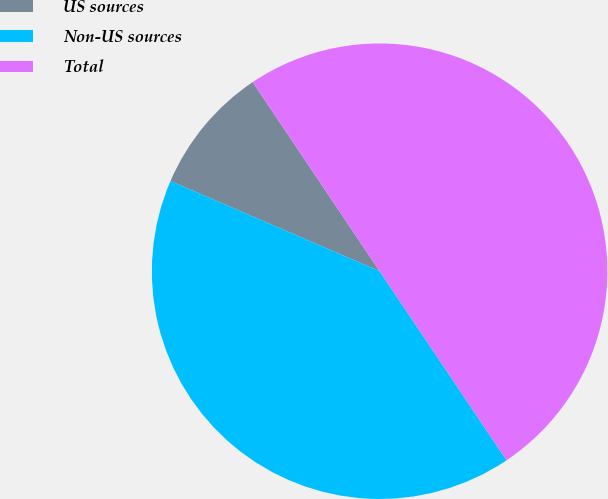Convert chart to OTSL. <chart><loc_0><loc_0><loc_500><loc_500><pie_chart><fcel>US sources<fcel>Non-US sources<fcel>Total<nl><fcel>9.11%<fcel>40.89%<fcel>50.0%<nl></chart> 